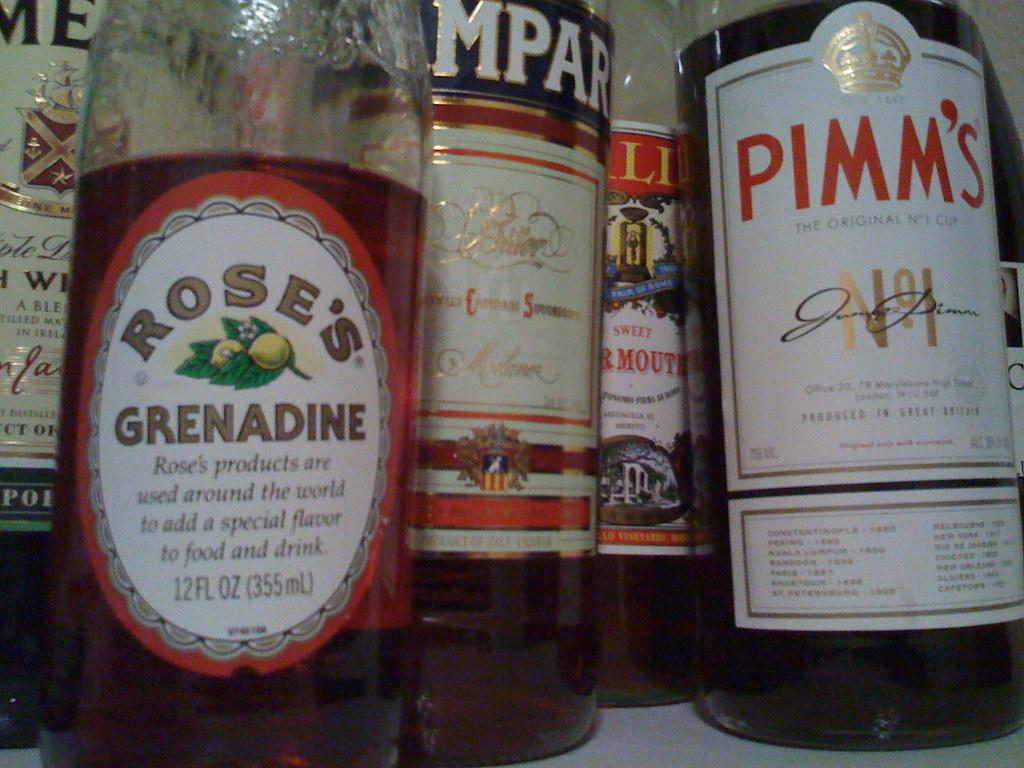Provide a one-sentence caption for the provided image. A shelf of bottles including Grenadine and Pimm's. 